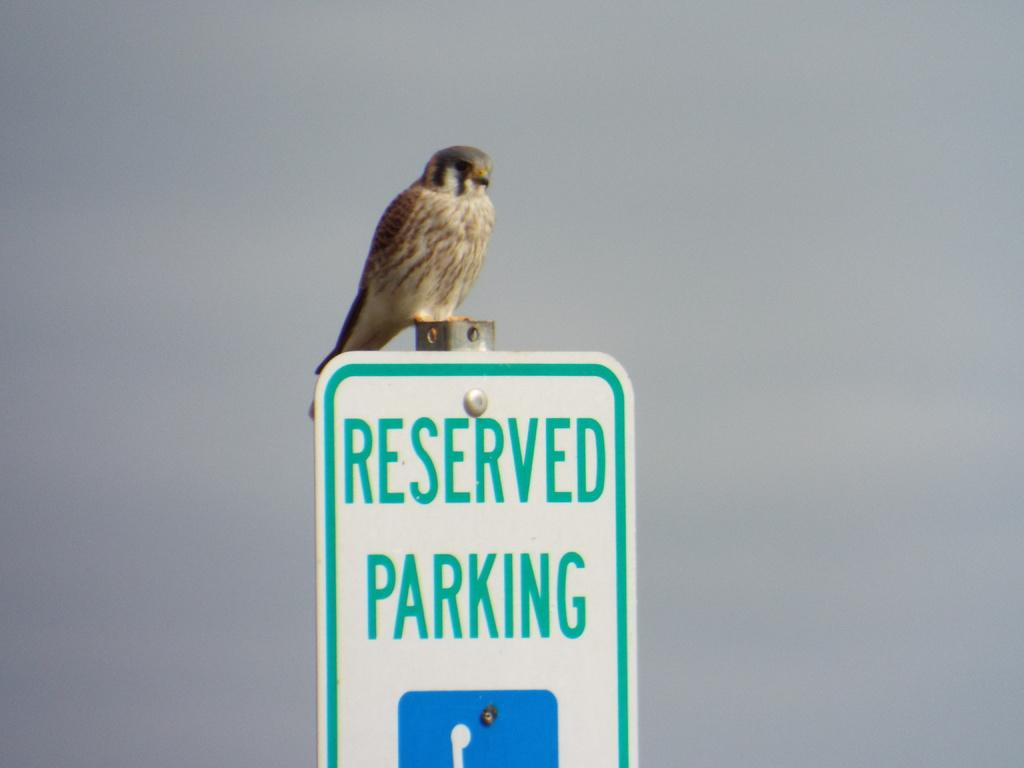What type of animal is present in the image? There is a bird in the image. Where is the bird located? The bird is on a signage board. What message is displayed on the signage board? The signage board has the text "reserved parking." What color is the silver fish that is sparkling in the image? There is no silver fish present in the image, and therefore no such sparkling can be observed. 